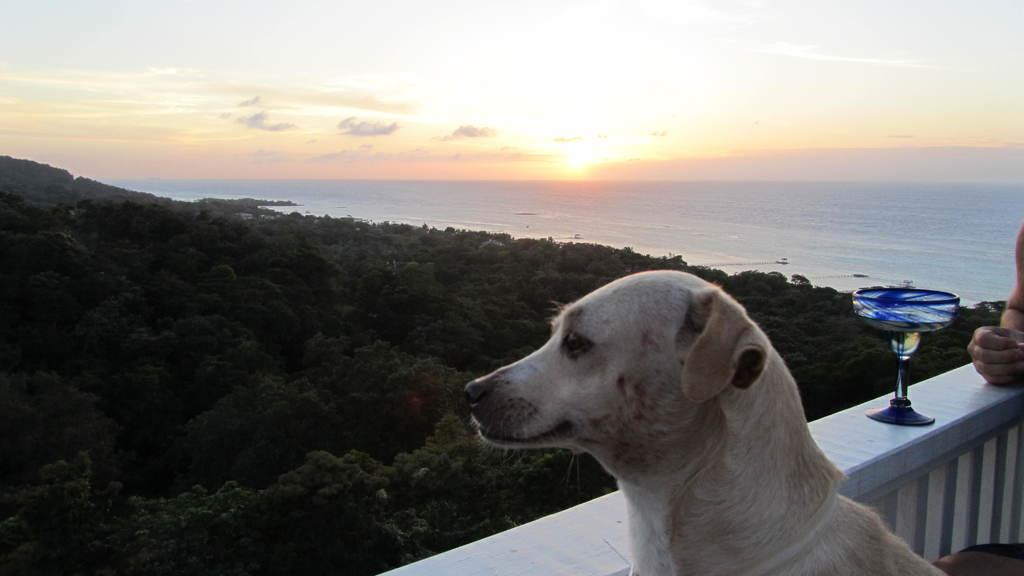What body part is visible in the image? Human hands are visible in the image. What object is placed on the railing in the hands are holding? There is a glass placed on a railing in the image. What type of animal is present in the image? There is a dog in the image. What type of vegetation can be seen in the image? Trees are present in the image. What part of the natural environment is visible in the image? The sky is visible in the image. What type of iron is being used to cover the duck in the image? There is no iron or duck present in the image. 